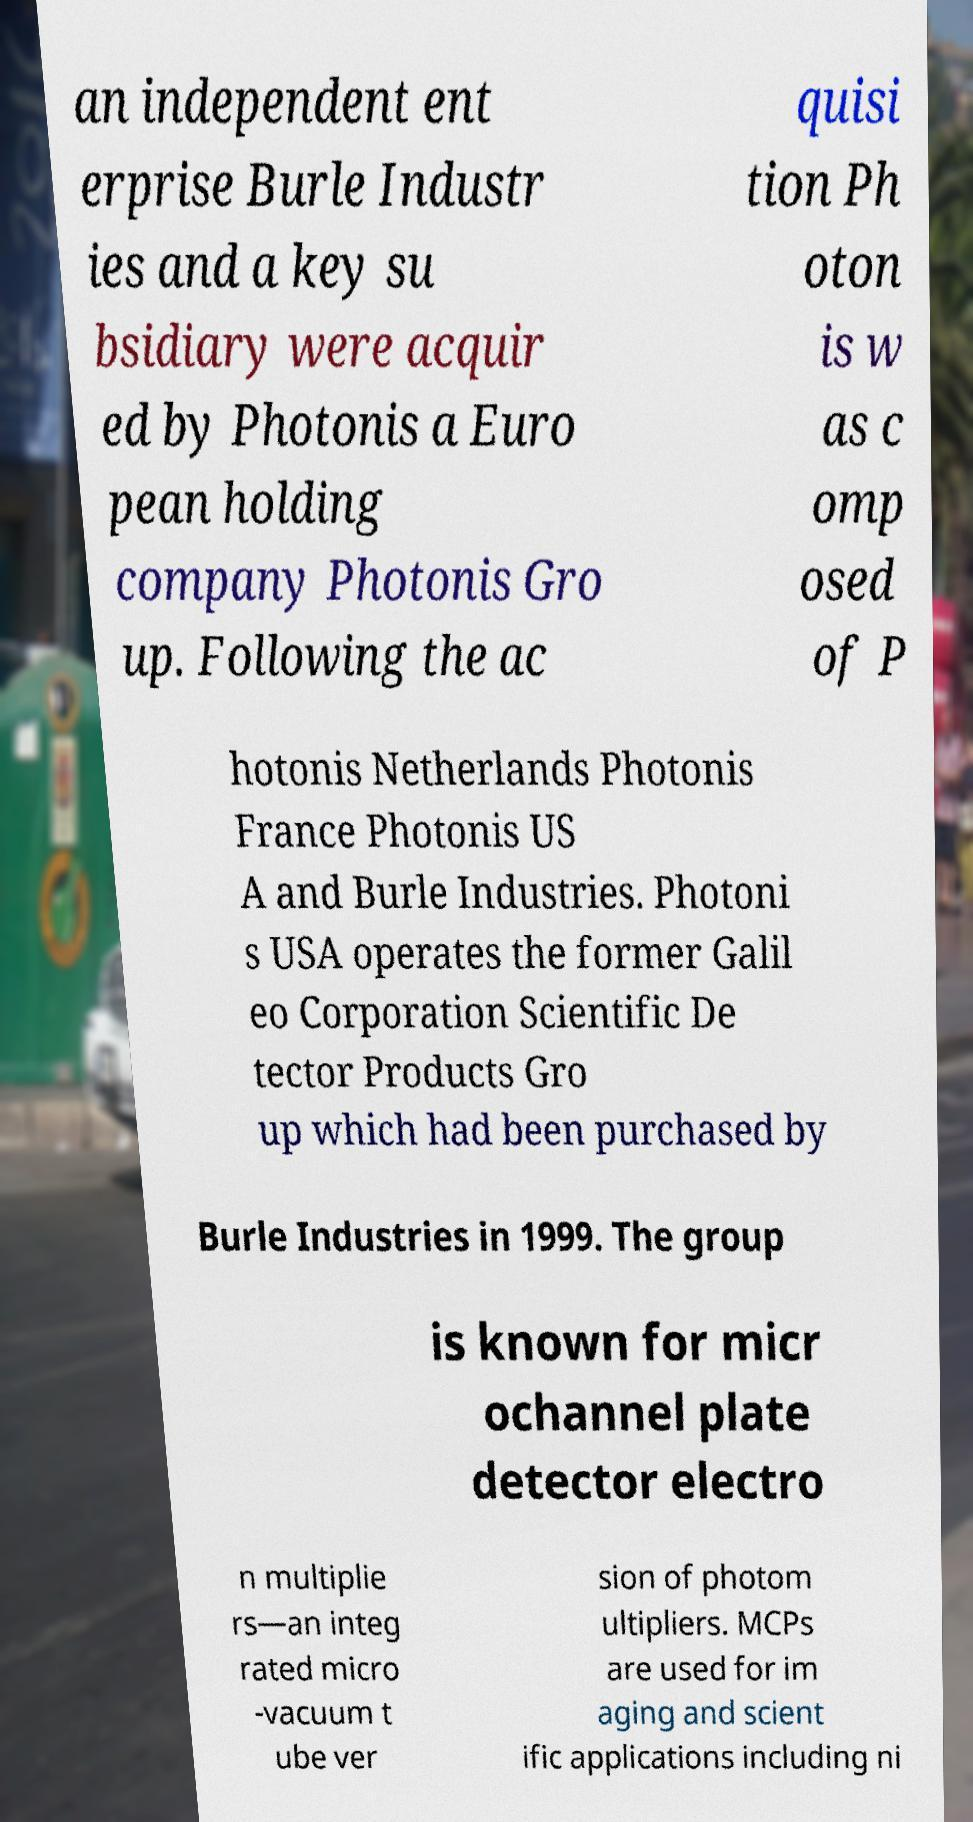There's text embedded in this image that I need extracted. Can you transcribe it verbatim? an independent ent erprise Burle Industr ies and a key su bsidiary were acquir ed by Photonis a Euro pean holding company Photonis Gro up. Following the ac quisi tion Ph oton is w as c omp osed of P hotonis Netherlands Photonis France Photonis US A and Burle Industries. Photoni s USA operates the former Galil eo Corporation Scientific De tector Products Gro up which had been purchased by Burle Industries in 1999. The group is known for micr ochannel plate detector electro n multiplie rs—an integ rated micro -vacuum t ube ver sion of photom ultipliers. MCPs are used for im aging and scient ific applications including ni 